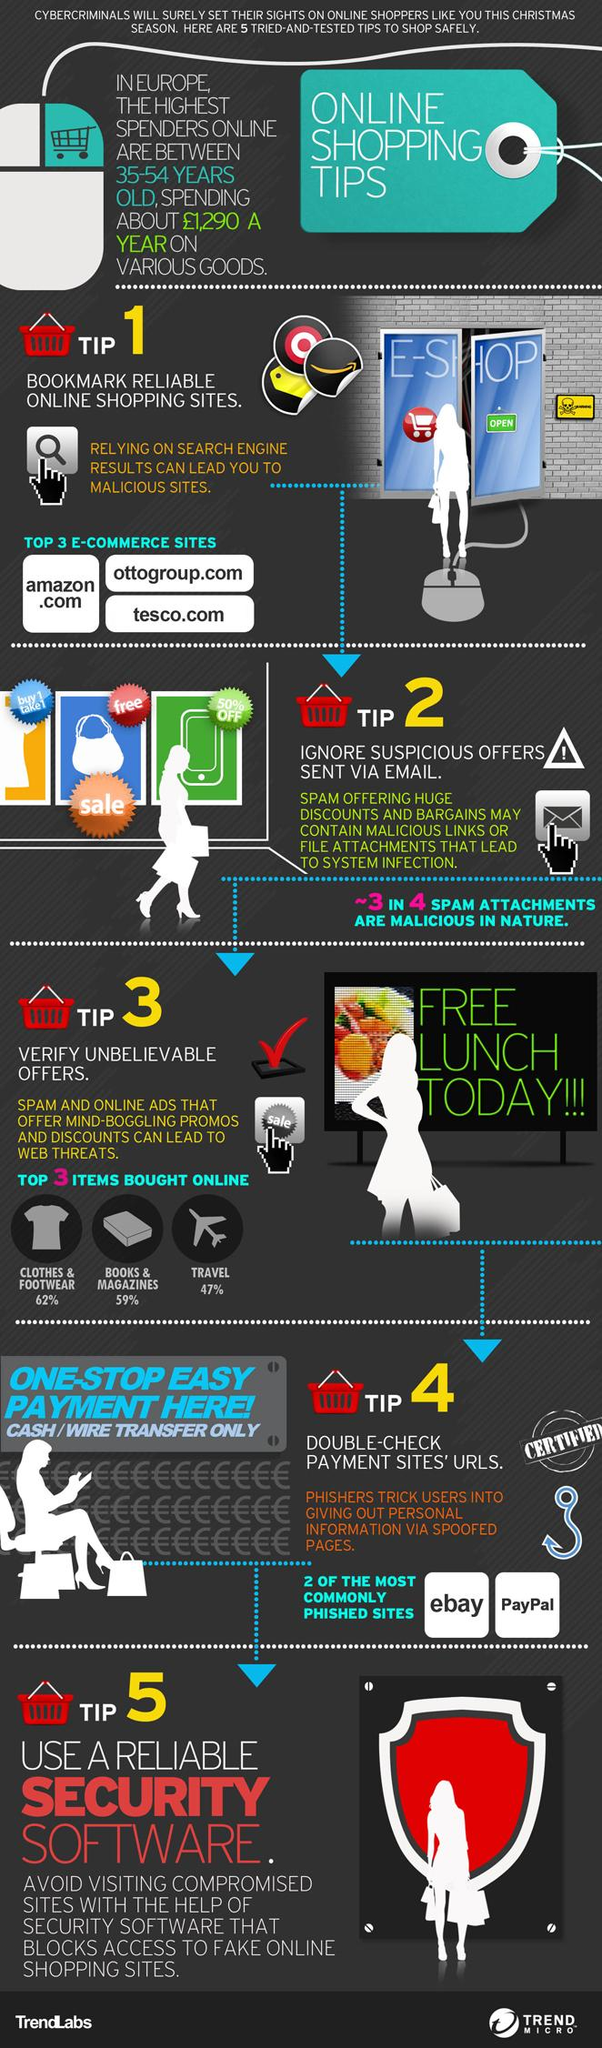Give some essential details in this illustration. Five tips are mentioned here. Some people believe that eBay and PayPal are unsafe payment sites. It is important to thoroughly review the URLs of payment sites in order to ensure the safety of online shopping transactions. According to recent statistics, approximately 75% of spam attachments are malicious. The top three items most frequently purchased online are clothes and footwear, books and magazines, and travel-related products. 